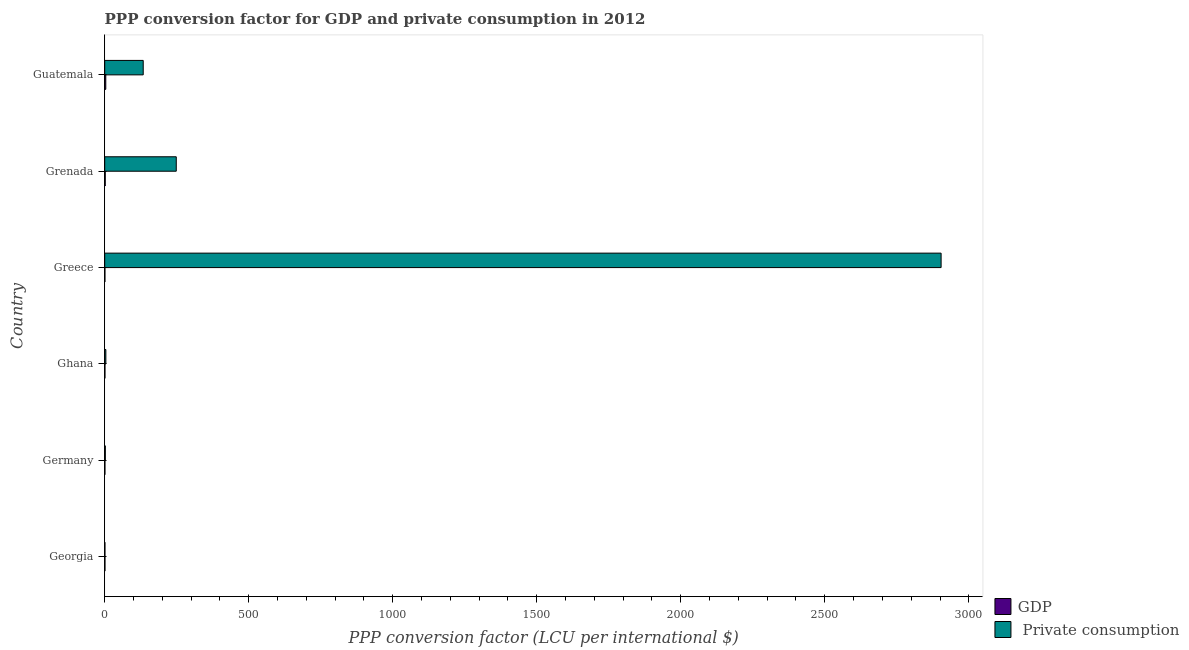Are the number of bars on each tick of the Y-axis equal?
Your answer should be very brief. Yes. How many bars are there on the 1st tick from the top?
Make the answer very short. 2. In how many cases, is the number of bars for a given country not equal to the number of legend labels?
Offer a very short reply. 0. What is the ppp conversion factor for private consumption in Guatemala?
Provide a succinct answer. 133.68. Across all countries, what is the maximum ppp conversion factor for gdp?
Keep it short and to the point. 3.68. Across all countries, what is the minimum ppp conversion factor for gdp?
Your response must be concise. 0.69. In which country was the ppp conversion factor for private consumption maximum?
Your answer should be compact. Greece. In which country was the ppp conversion factor for private consumption minimum?
Give a very brief answer. Georgia. What is the total ppp conversion factor for private consumption in the graph?
Your response must be concise. 3292.74. What is the difference between the ppp conversion factor for private consumption in Greece and that in Grenada?
Make the answer very short. 2655.49. What is the difference between the ppp conversion factor for private consumption in Ghana and the ppp conversion factor for gdp in Georgia?
Keep it short and to the point. 3.08. What is the average ppp conversion factor for gdp per country?
Provide a succinct answer. 1.44. What is the difference between the ppp conversion factor for gdp and ppp conversion factor for private consumption in Georgia?
Give a very brief answer. 0.1. What is the ratio of the ppp conversion factor for gdp in Ghana to that in Grenada?
Your answer should be very brief. 0.43. Is the ppp conversion factor for private consumption in Greece less than that in Guatemala?
Your answer should be very brief. No. Is the difference between the ppp conversion factor for private consumption in Germany and Ghana greater than the difference between the ppp conversion factor for gdp in Germany and Ghana?
Provide a succinct answer. No. What is the difference between the highest and the second highest ppp conversion factor for gdp?
Give a very brief answer. 1.86. What is the difference between the highest and the lowest ppp conversion factor for private consumption?
Provide a short and direct response. 2903.13. What does the 2nd bar from the top in Ghana represents?
Offer a terse response. GDP. What does the 2nd bar from the bottom in Grenada represents?
Keep it short and to the point.  Private consumption. How many bars are there?
Keep it short and to the point. 12. How many countries are there in the graph?
Your answer should be very brief. 6. What is the difference between two consecutive major ticks on the X-axis?
Keep it short and to the point. 500. Does the graph contain any zero values?
Ensure brevity in your answer.  No. How are the legend labels stacked?
Give a very brief answer. Vertical. What is the title of the graph?
Give a very brief answer. PPP conversion factor for GDP and private consumption in 2012. What is the label or title of the X-axis?
Ensure brevity in your answer.  PPP conversion factor (LCU per international $). What is the label or title of the Y-axis?
Your answer should be very brief. Country. What is the PPP conversion factor (LCU per international $) in GDP in Georgia?
Ensure brevity in your answer.  0.85. What is the PPP conversion factor (LCU per international $) in  Private consumption in Georgia?
Ensure brevity in your answer.  0.75. What is the PPP conversion factor (LCU per international $) of GDP in Germany?
Your answer should be very brief. 0.79. What is the PPP conversion factor (LCU per international $) of  Private consumption in Germany?
Give a very brief answer. 2.1. What is the PPP conversion factor (LCU per international $) of GDP in Ghana?
Your answer should be very brief. 0.79. What is the PPP conversion factor (LCU per international $) of  Private consumption in Ghana?
Your answer should be compact. 3.94. What is the PPP conversion factor (LCU per international $) of GDP in Greece?
Offer a terse response. 0.69. What is the PPP conversion factor (LCU per international $) of  Private consumption in Greece?
Keep it short and to the point. 2903.88. What is the PPP conversion factor (LCU per international $) of GDP in Grenada?
Offer a terse response. 1.82. What is the PPP conversion factor (LCU per international $) in  Private consumption in Grenada?
Provide a succinct answer. 248.38. What is the PPP conversion factor (LCU per international $) in GDP in Guatemala?
Give a very brief answer. 3.68. What is the PPP conversion factor (LCU per international $) in  Private consumption in Guatemala?
Offer a terse response. 133.68. Across all countries, what is the maximum PPP conversion factor (LCU per international $) of GDP?
Offer a very short reply. 3.68. Across all countries, what is the maximum PPP conversion factor (LCU per international $) in  Private consumption?
Keep it short and to the point. 2903.88. Across all countries, what is the minimum PPP conversion factor (LCU per international $) of GDP?
Keep it short and to the point. 0.69. Across all countries, what is the minimum PPP conversion factor (LCU per international $) of  Private consumption?
Keep it short and to the point. 0.75. What is the total PPP conversion factor (LCU per international $) of GDP in the graph?
Provide a succinct answer. 8.62. What is the total PPP conversion factor (LCU per international $) of  Private consumption in the graph?
Give a very brief answer. 3292.74. What is the difference between the PPP conversion factor (LCU per international $) in GDP in Georgia and that in Germany?
Offer a very short reply. 0.07. What is the difference between the PPP conversion factor (LCU per international $) of  Private consumption in Georgia and that in Germany?
Make the answer very short. -1.35. What is the difference between the PPP conversion factor (LCU per international $) of GDP in Georgia and that in Ghana?
Ensure brevity in your answer.  0.06. What is the difference between the PPP conversion factor (LCU per international $) in  Private consumption in Georgia and that in Ghana?
Provide a short and direct response. -3.19. What is the difference between the PPP conversion factor (LCU per international $) in GDP in Georgia and that in Greece?
Provide a short and direct response. 0.17. What is the difference between the PPP conversion factor (LCU per international $) of  Private consumption in Georgia and that in Greece?
Your response must be concise. -2903.13. What is the difference between the PPP conversion factor (LCU per international $) of GDP in Georgia and that in Grenada?
Offer a very short reply. -0.97. What is the difference between the PPP conversion factor (LCU per international $) in  Private consumption in Georgia and that in Grenada?
Give a very brief answer. -247.63. What is the difference between the PPP conversion factor (LCU per international $) of GDP in Georgia and that in Guatemala?
Ensure brevity in your answer.  -2.83. What is the difference between the PPP conversion factor (LCU per international $) in  Private consumption in Georgia and that in Guatemala?
Provide a short and direct response. -132.93. What is the difference between the PPP conversion factor (LCU per international $) of GDP in Germany and that in Ghana?
Keep it short and to the point. -0.01. What is the difference between the PPP conversion factor (LCU per international $) of  Private consumption in Germany and that in Ghana?
Provide a succinct answer. -1.84. What is the difference between the PPP conversion factor (LCU per international $) in GDP in Germany and that in Greece?
Keep it short and to the point. 0.1. What is the difference between the PPP conversion factor (LCU per international $) in  Private consumption in Germany and that in Greece?
Ensure brevity in your answer.  -2901.78. What is the difference between the PPP conversion factor (LCU per international $) of GDP in Germany and that in Grenada?
Ensure brevity in your answer.  -1.03. What is the difference between the PPP conversion factor (LCU per international $) of  Private consumption in Germany and that in Grenada?
Offer a terse response. -246.29. What is the difference between the PPP conversion factor (LCU per international $) of GDP in Germany and that in Guatemala?
Provide a short and direct response. -2.89. What is the difference between the PPP conversion factor (LCU per international $) in  Private consumption in Germany and that in Guatemala?
Ensure brevity in your answer.  -131.58. What is the difference between the PPP conversion factor (LCU per international $) of GDP in Ghana and that in Greece?
Keep it short and to the point. 0.1. What is the difference between the PPP conversion factor (LCU per international $) of  Private consumption in Ghana and that in Greece?
Provide a succinct answer. -2899.94. What is the difference between the PPP conversion factor (LCU per international $) in GDP in Ghana and that in Grenada?
Keep it short and to the point. -1.03. What is the difference between the PPP conversion factor (LCU per international $) in  Private consumption in Ghana and that in Grenada?
Give a very brief answer. -244.45. What is the difference between the PPP conversion factor (LCU per international $) of GDP in Ghana and that in Guatemala?
Offer a terse response. -2.89. What is the difference between the PPP conversion factor (LCU per international $) of  Private consumption in Ghana and that in Guatemala?
Offer a very short reply. -129.74. What is the difference between the PPP conversion factor (LCU per international $) of GDP in Greece and that in Grenada?
Give a very brief answer. -1.13. What is the difference between the PPP conversion factor (LCU per international $) of  Private consumption in Greece and that in Grenada?
Give a very brief answer. 2655.5. What is the difference between the PPP conversion factor (LCU per international $) of GDP in Greece and that in Guatemala?
Offer a terse response. -2.99. What is the difference between the PPP conversion factor (LCU per international $) in  Private consumption in Greece and that in Guatemala?
Give a very brief answer. 2770.2. What is the difference between the PPP conversion factor (LCU per international $) in GDP in Grenada and that in Guatemala?
Your answer should be very brief. -1.86. What is the difference between the PPP conversion factor (LCU per international $) in  Private consumption in Grenada and that in Guatemala?
Offer a terse response. 114.7. What is the difference between the PPP conversion factor (LCU per international $) in GDP in Georgia and the PPP conversion factor (LCU per international $) in  Private consumption in Germany?
Your response must be concise. -1.24. What is the difference between the PPP conversion factor (LCU per international $) in GDP in Georgia and the PPP conversion factor (LCU per international $) in  Private consumption in Ghana?
Ensure brevity in your answer.  -3.08. What is the difference between the PPP conversion factor (LCU per international $) in GDP in Georgia and the PPP conversion factor (LCU per international $) in  Private consumption in Greece?
Give a very brief answer. -2903.03. What is the difference between the PPP conversion factor (LCU per international $) of GDP in Georgia and the PPP conversion factor (LCU per international $) of  Private consumption in Grenada?
Your response must be concise. -247.53. What is the difference between the PPP conversion factor (LCU per international $) of GDP in Georgia and the PPP conversion factor (LCU per international $) of  Private consumption in Guatemala?
Your response must be concise. -132.83. What is the difference between the PPP conversion factor (LCU per international $) of GDP in Germany and the PPP conversion factor (LCU per international $) of  Private consumption in Ghana?
Make the answer very short. -3.15. What is the difference between the PPP conversion factor (LCU per international $) in GDP in Germany and the PPP conversion factor (LCU per international $) in  Private consumption in Greece?
Make the answer very short. -2903.09. What is the difference between the PPP conversion factor (LCU per international $) in GDP in Germany and the PPP conversion factor (LCU per international $) in  Private consumption in Grenada?
Offer a very short reply. -247.6. What is the difference between the PPP conversion factor (LCU per international $) in GDP in Germany and the PPP conversion factor (LCU per international $) in  Private consumption in Guatemala?
Your answer should be compact. -132.9. What is the difference between the PPP conversion factor (LCU per international $) in GDP in Ghana and the PPP conversion factor (LCU per international $) in  Private consumption in Greece?
Offer a terse response. -2903.09. What is the difference between the PPP conversion factor (LCU per international $) of GDP in Ghana and the PPP conversion factor (LCU per international $) of  Private consumption in Grenada?
Offer a terse response. -247.59. What is the difference between the PPP conversion factor (LCU per international $) of GDP in Ghana and the PPP conversion factor (LCU per international $) of  Private consumption in Guatemala?
Keep it short and to the point. -132.89. What is the difference between the PPP conversion factor (LCU per international $) in GDP in Greece and the PPP conversion factor (LCU per international $) in  Private consumption in Grenada?
Provide a short and direct response. -247.7. What is the difference between the PPP conversion factor (LCU per international $) of GDP in Greece and the PPP conversion factor (LCU per international $) of  Private consumption in Guatemala?
Offer a terse response. -132.99. What is the difference between the PPP conversion factor (LCU per international $) of GDP in Grenada and the PPP conversion factor (LCU per international $) of  Private consumption in Guatemala?
Offer a terse response. -131.86. What is the average PPP conversion factor (LCU per international $) in GDP per country?
Your answer should be compact. 1.44. What is the average PPP conversion factor (LCU per international $) of  Private consumption per country?
Provide a short and direct response. 548.79. What is the difference between the PPP conversion factor (LCU per international $) of GDP and PPP conversion factor (LCU per international $) of  Private consumption in Georgia?
Your answer should be compact. 0.1. What is the difference between the PPP conversion factor (LCU per international $) of GDP and PPP conversion factor (LCU per international $) of  Private consumption in Germany?
Your answer should be very brief. -1.31. What is the difference between the PPP conversion factor (LCU per international $) in GDP and PPP conversion factor (LCU per international $) in  Private consumption in Ghana?
Your response must be concise. -3.15. What is the difference between the PPP conversion factor (LCU per international $) in GDP and PPP conversion factor (LCU per international $) in  Private consumption in Greece?
Your answer should be very brief. -2903.19. What is the difference between the PPP conversion factor (LCU per international $) of GDP and PPP conversion factor (LCU per international $) of  Private consumption in Grenada?
Keep it short and to the point. -246.56. What is the difference between the PPP conversion factor (LCU per international $) in GDP and PPP conversion factor (LCU per international $) in  Private consumption in Guatemala?
Offer a terse response. -130. What is the ratio of the PPP conversion factor (LCU per international $) of GDP in Georgia to that in Germany?
Keep it short and to the point. 1.09. What is the ratio of the PPP conversion factor (LCU per international $) of  Private consumption in Georgia to that in Germany?
Provide a succinct answer. 0.36. What is the ratio of the PPP conversion factor (LCU per international $) of GDP in Georgia to that in Ghana?
Your response must be concise. 1.08. What is the ratio of the PPP conversion factor (LCU per international $) in  Private consumption in Georgia to that in Ghana?
Offer a very short reply. 0.19. What is the ratio of the PPP conversion factor (LCU per international $) of GDP in Georgia to that in Greece?
Ensure brevity in your answer.  1.24. What is the ratio of the PPP conversion factor (LCU per international $) of GDP in Georgia to that in Grenada?
Provide a short and direct response. 0.47. What is the ratio of the PPP conversion factor (LCU per international $) of  Private consumption in Georgia to that in Grenada?
Your answer should be compact. 0. What is the ratio of the PPP conversion factor (LCU per international $) of GDP in Georgia to that in Guatemala?
Provide a succinct answer. 0.23. What is the ratio of the PPP conversion factor (LCU per international $) of  Private consumption in Georgia to that in Guatemala?
Keep it short and to the point. 0.01. What is the ratio of the PPP conversion factor (LCU per international $) of GDP in Germany to that in Ghana?
Provide a short and direct response. 0.99. What is the ratio of the PPP conversion factor (LCU per international $) in  Private consumption in Germany to that in Ghana?
Your response must be concise. 0.53. What is the ratio of the PPP conversion factor (LCU per international $) in GDP in Germany to that in Greece?
Provide a succinct answer. 1.14. What is the ratio of the PPP conversion factor (LCU per international $) of  Private consumption in Germany to that in Greece?
Your response must be concise. 0. What is the ratio of the PPP conversion factor (LCU per international $) in GDP in Germany to that in Grenada?
Provide a succinct answer. 0.43. What is the ratio of the PPP conversion factor (LCU per international $) of  Private consumption in Germany to that in Grenada?
Give a very brief answer. 0.01. What is the ratio of the PPP conversion factor (LCU per international $) of GDP in Germany to that in Guatemala?
Ensure brevity in your answer.  0.21. What is the ratio of the PPP conversion factor (LCU per international $) of  Private consumption in Germany to that in Guatemala?
Ensure brevity in your answer.  0.02. What is the ratio of the PPP conversion factor (LCU per international $) of GDP in Ghana to that in Greece?
Your answer should be very brief. 1.15. What is the ratio of the PPP conversion factor (LCU per international $) of  Private consumption in Ghana to that in Greece?
Provide a succinct answer. 0. What is the ratio of the PPP conversion factor (LCU per international $) in GDP in Ghana to that in Grenada?
Offer a terse response. 0.43. What is the ratio of the PPP conversion factor (LCU per international $) of  Private consumption in Ghana to that in Grenada?
Your response must be concise. 0.02. What is the ratio of the PPP conversion factor (LCU per international $) in GDP in Ghana to that in Guatemala?
Your answer should be compact. 0.22. What is the ratio of the PPP conversion factor (LCU per international $) of  Private consumption in Ghana to that in Guatemala?
Your answer should be very brief. 0.03. What is the ratio of the PPP conversion factor (LCU per international $) of GDP in Greece to that in Grenada?
Give a very brief answer. 0.38. What is the ratio of the PPP conversion factor (LCU per international $) of  Private consumption in Greece to that in Grenada?
Keep it short and to the point. 11.69. What is the ratio of the PPP conversion factor (LCU per international $) of GDP in Greece to that in Guatemala?
Provide a succinct answer. 0.19. What is the ratio of the PPP conversion factor (LCU per international $) in  Private consumption in Greece to that in Guatemala?
Your response must be concise. 21.72. What is the ratio of the PPP conversion factor (LCU per international $) of GDP in Grenada to that in Guatemala?
Offer a very short reply. 0.49. What is the ratio of the PPP conversion factor (LCU per international $) in  Private consumption in Grenada to that in Guatemala?
Provide a short and direct response. 1.86. What is the difference between the highest and the second highest PPP conversion factor (LCU per international $) in GDP?
Your answer should be compact. 1.86. What is the difference between the highest and the second highest PPP conversion factor (LCU per international $) of  Private consumption?
Provide a short and direct response. 2655.5. What is the difference between the highest and the lowest PPP conversion factor (LCU per international $) of GDP?
Provide a succinct answer. 2.99. What is the difference between the highest and the lowest PPP conversion factor (LCU per international $) in  Private consumption?
Your answer should be compact. 2903.13. 